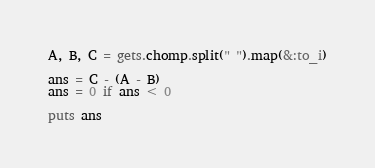Convert code to text. <code><loc_0><loc_0><loc_500><loc_500><_Ruby_>A, B, C = gets.chomp.split(" ").map(&:to_i)

ans = C - (A - B)
ans = 0 if ans < 0

puts ans
</code> 